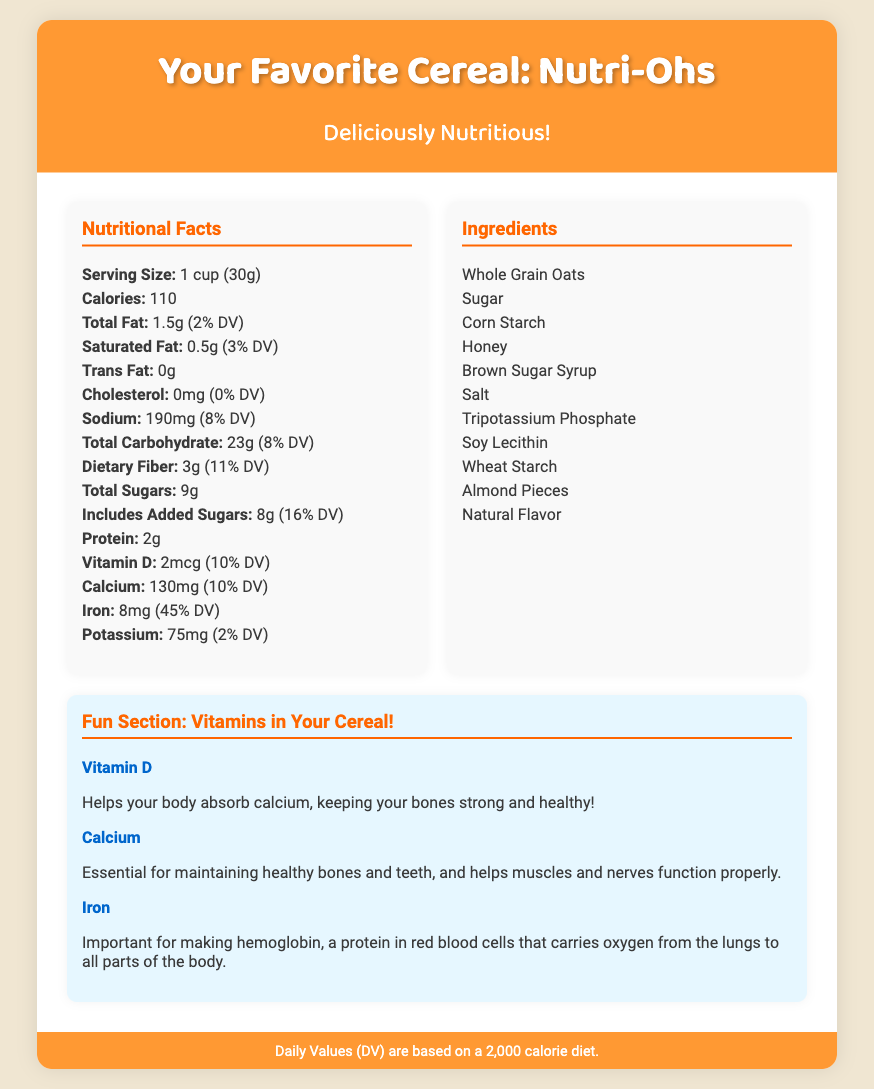What is the serving size of Nutri-Ohs? The serving size is mentioned in the Nutritional Facts section of the document. It is 1 cup (30g).
Answer: 1 cup (30g) How many calories are in one serving? The calorie count is listed under the Nutritional Facts section. It indicates that there are 110 calories per serving.
Answer: 110 What is the total sugar content? The document specifies the total sugars in the Nutritional Facts section, which is 9g.
Answer: 9g Which ingredient is used to sweeten the cereal? The ingredients section lists several items, including sugar and honey, commonly used as sweeteners.
Answer: Sugar What is the percentage of daily value for iron? The Daily Value for iron is provided in the Nutritional Facts section, listed as 45% DV.
Answer: 45% DV Why is vitamin D important? The Fun Section explains that vitamin D helps absorb calcium, which is crucial for bone health.
Answer: Absorb calcium How many different vitamins are mentioned in the fun section? The fun section lists the vitamins discussed, which are three: Vitamin D, Calcium, and Iron.
Answer: Three What are the whole ingredients used in Nutri-Ohs? The ingredients section of the document lists the whole ingredients, starting with Whole Grain Oats.
Answer: Whole Grain Oats What does DV stand for? The footer explains that DV stands for Daily Values, based on a 2,000 calorie diet.
Answer: Daily Values 